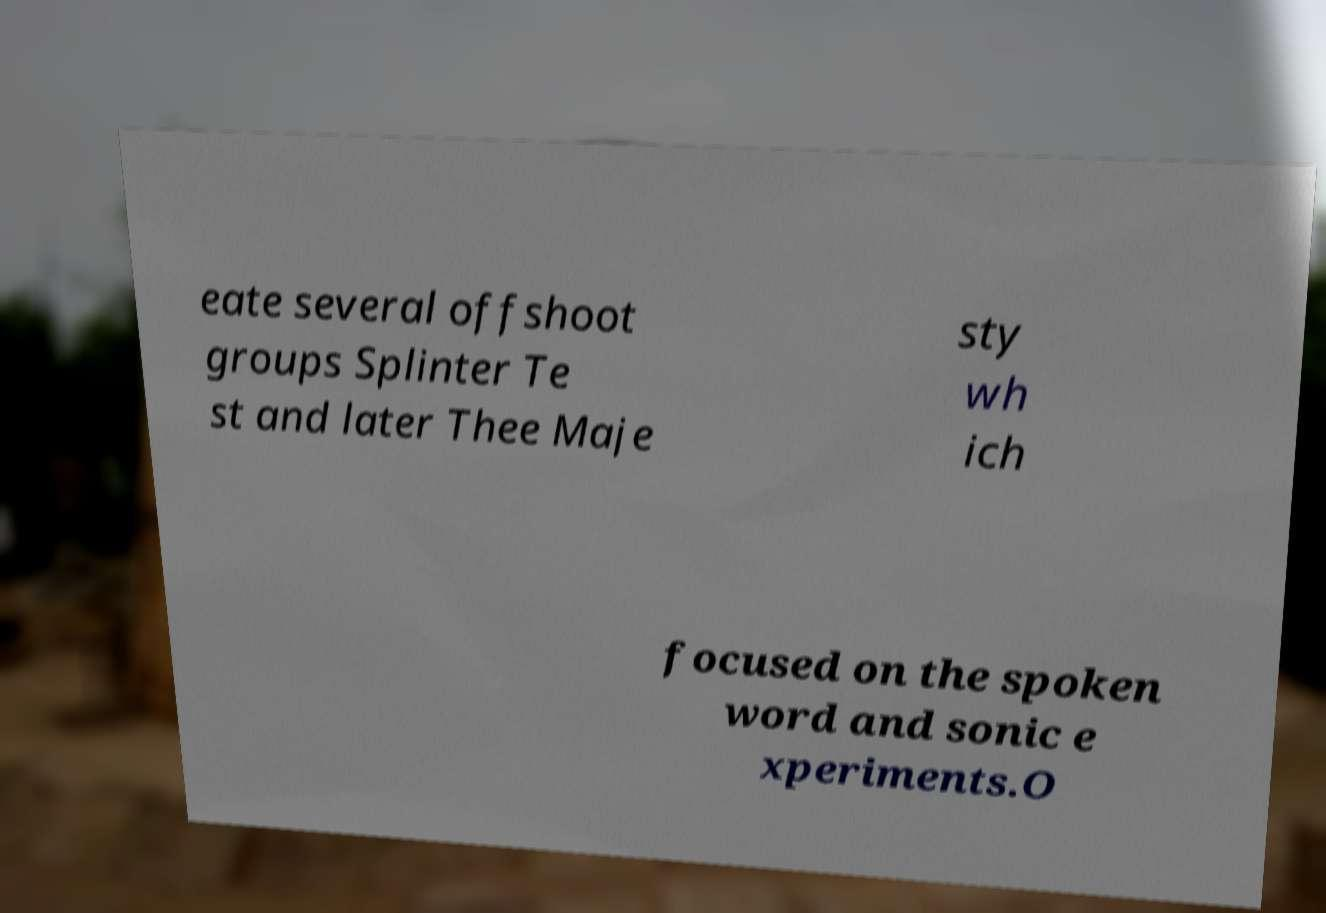I need the written content from this picture converted into text. Can you do that? eate several offshoot groups Splinter Te st and later Thee Maje sty wh ich focused on the spoken word and sonic e xperiments.O 